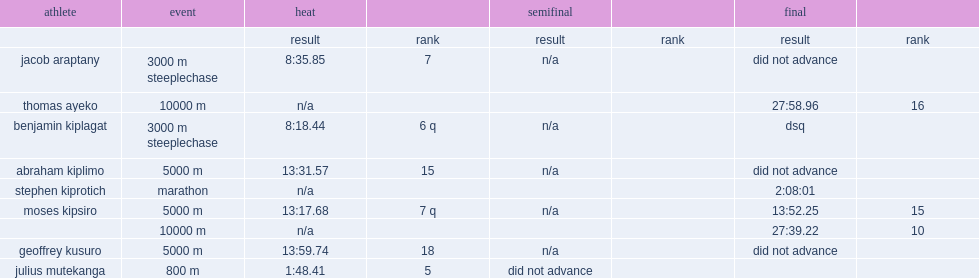What was the rank did mutekanga finish with a time of one minute and 48.41 seconds? 5.0. 